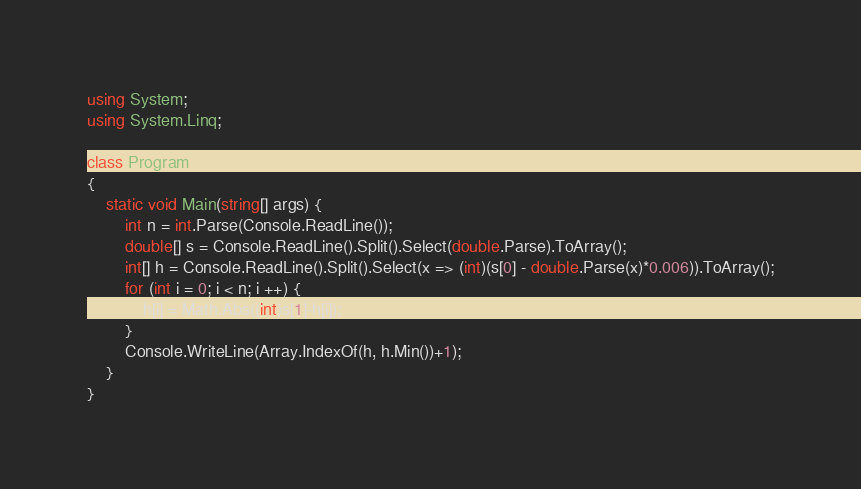<code> <loc_0><loc_0><loc_500><loc_500><_C#_>using System;
using System.Linq;

class Program
{
    static void Main(string[] args) {
        int n = int.Parse(Console.ReadLine());
        double[] s = Console.ReadLine().Split().Select(double.Parse).ToArray();
        int[] h = Console.ReadLine().Split().Select(x => (int)(s[0] - double.Parse(x)*0.006)).ToArray();
        for (int i = 0; i < n; i ++) {
            h[i] = Math.Abs((int)s[1]-h[i]);
        }
        Console.WriteLine(Array.IndexOf(h, h.Min())+1);
    }
}</code> 